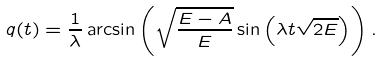Convert formula to latex. <formula><loc_0><loc_0><loc_500><loc_500>q ( t ) = \frac { 1 } { \lambda } \arcsin \left ( \sqrt { \frac { E - A } { E } } \sin \left ( \lambda t \sqrt { 2 E } \right ) \right ) .</formula> 